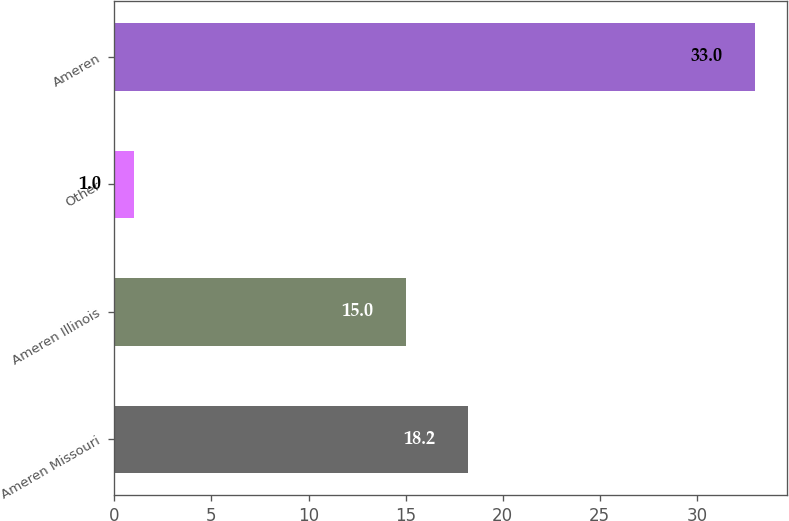Convert chart to OTSL. <chart><loc_0><loc_0><loc_500><loc_500><bar_chart><fcel>Ameren Missouri<fcel>Ameren Illinois<fcel>Other<fcel>Ameren<nl><fcel>18.2<fcel>15<fcel>1<fcel>33<nl></chart> 